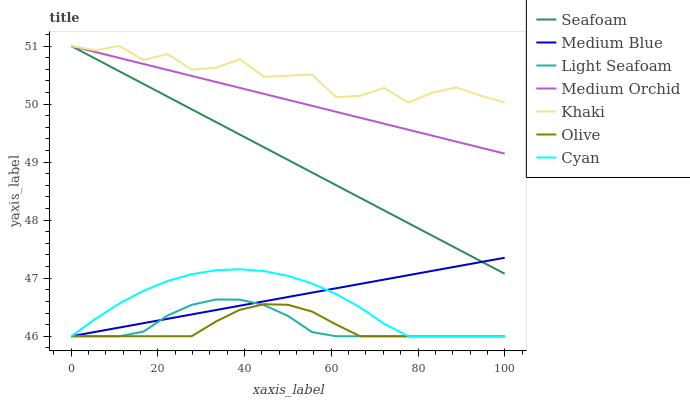Does Olive have the minimum area under the curve?
Answer yes or no. Yes. Does Khaki have the maximum area under the curve?
Answer yes or no. Yes. Does Medium Orchid have the minimum area under the curve?
Answer yes or no. No. Does Medium Orchid have the maximum area under the curve?
Answer yes or no. No. Is Medium Blue the smoothest?
Answer yes or no. Yes. Is Khaki the roughest?
Answer yes or no. Yes. Is Medium Orchid the smoothest?
Answer yes or no. No. Is Medium Orchid the roughest?
Answer yes or no. No. Does Medium Blue have the lowest value?
Answer yes or no. Yes. Does Medium Orchid have the lowest value?
Answer yes or no. No. Does Seafoam have the highest value?
Answer yes or no. Yes. Does Medium Blue have the highest value?
Answer yes or no. No. Is Olive less than Medium Orchid?
Answer yes or no. Yes. Is Khaki greater than Light Seafoam?
Answer yes or no. Yes. Does Light Seafoam intersect Cyan?
Answer yes or no. Yes. Is Light Seafoam less than Cyan?
Answer yes or no. No. Is Light Seafoam greater than Cyan?
Answer yes or no. No. Does Olive intersect Medium Orchid?
Answer yes or no. No. 